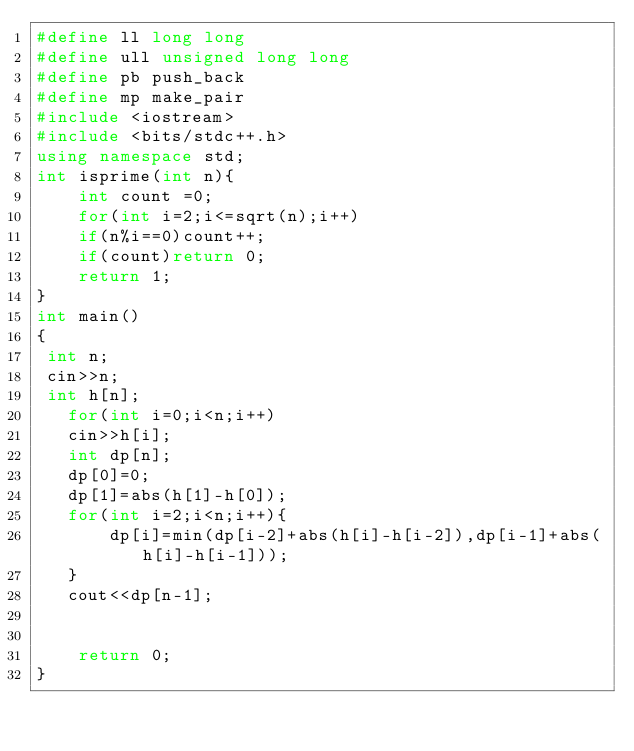<code> <loc_0><loc_0><loc_500><loc_500><_C++_>#define ll long long
#define ull unsigned long long
#define pb push_back
#define mp make_pair
#include <iostream>
#include <bits/stdc++.h>
using namespace std;
int isprime(int n){
    int count =0;
    for(int i=2;i<=sqrt(n);i++)
    if(n%i==0)count++;
    if(count)return 0;
    return 1;
}
int main()
{
 int n;
 cin>>n;
 int h[n];
   for(int i=0;i<n;i++)
   cin>>h[i];
   int dp[n];
   dp[0]=0;
   dp[1]=abs(h[1]-h[0]);
   for(int i=2;i<n;i++){
       dp[i]=min(dp[i-2]+abs(h[i]-h[i-2]),dp[i-1]+abs(h[i]-h[i-1]));
   }
   cout<<dp[n-1];
   

    return 0;
}</code> 